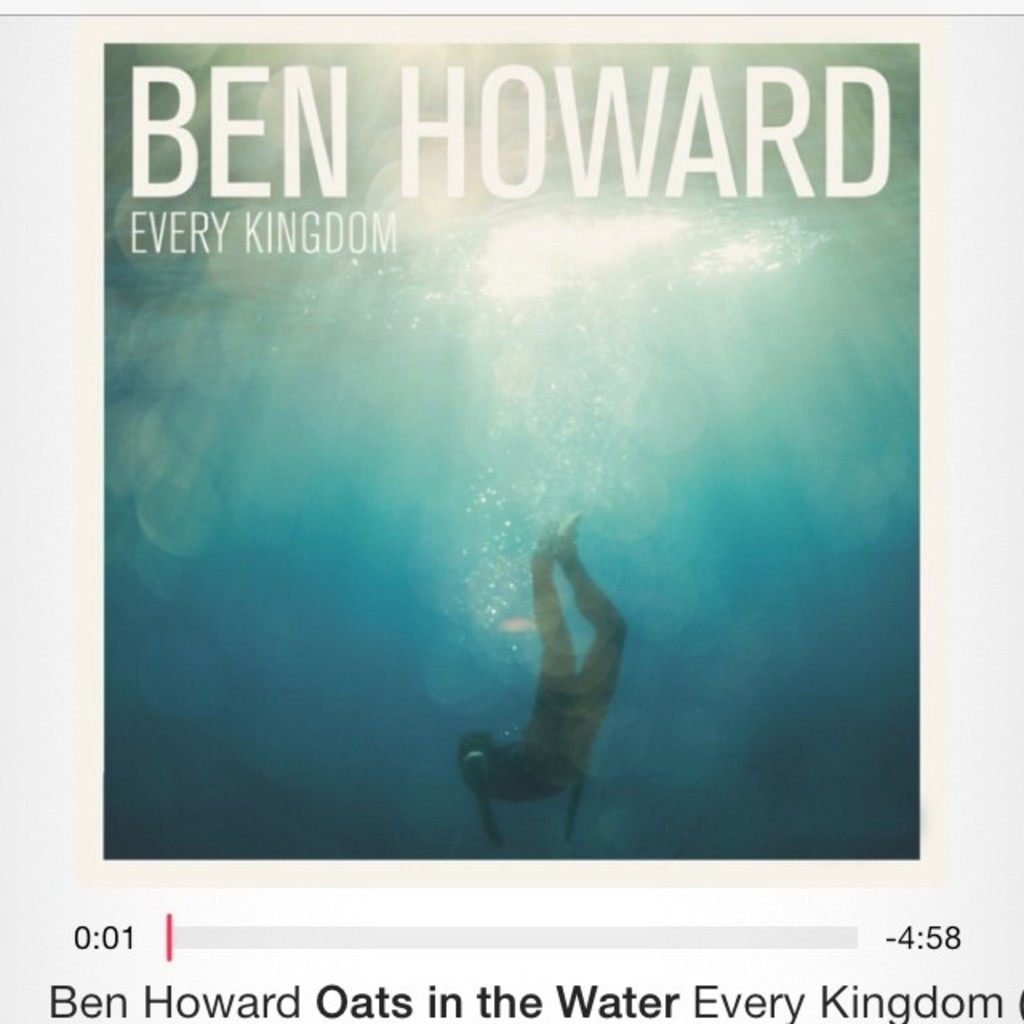Write a detailed description of the given image. The image presents the evocative album cover for 'Every Kingdom' by Ben Howard. It features a surreal depiction of a figure diving towards the underwater depths, bathed in a cascade of shimmering light from above, which infuses the scene with a dreamlike quality. The cover art uses a captivating gradient of blues and greens, symbolizing tranquility and the depths of the sea. The artist's name and album title are displayed in a clear, bold white font at the top, harmonizing with the ethereal aesthetic. A red progress bar at the bottom indicates the track 'Oats in the Water' with its playback time, seamlessly integrating information with artistic representation. 